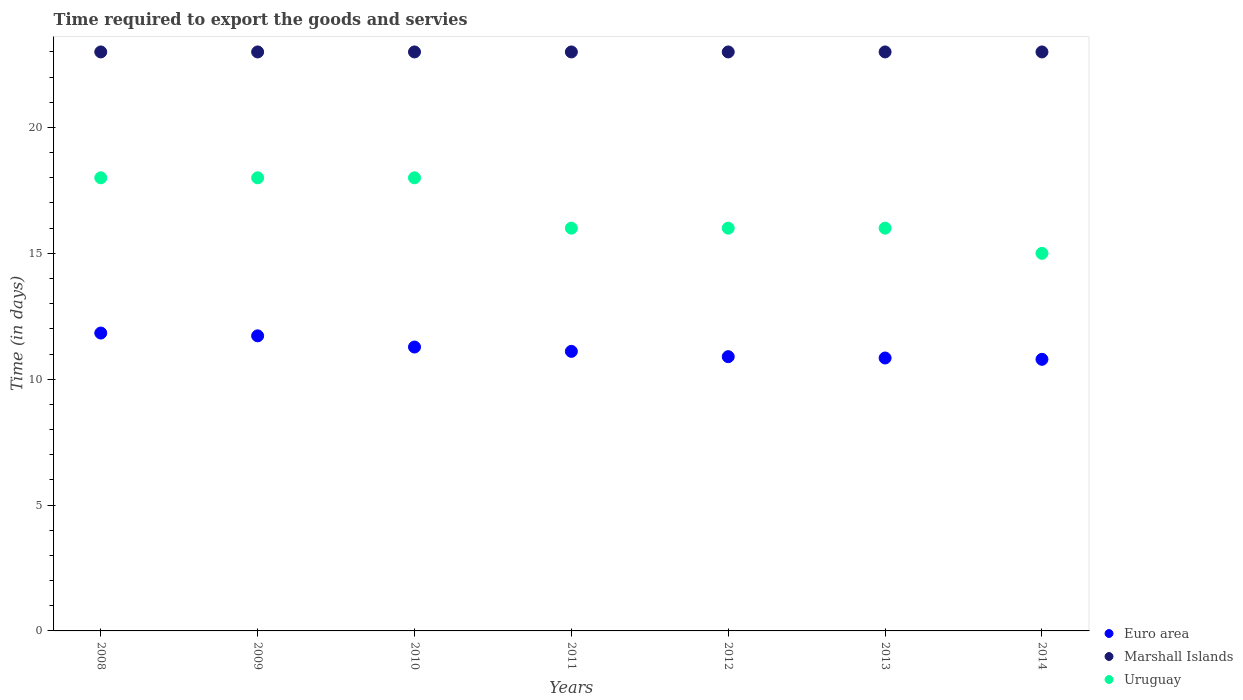Is the number of dotlines equal to the number of legend labels?
Your answer should be very brief. Yes. What is the number of days required to export the goods and services in Marshall Islands in 2014?
Keep it short and to the point. 23. Across all years, what is the maximum number of days required to export the goods and services in Marshall Islands?
Your answer should be very brief. 23. Across all years, what is the minimum number of days required to export the goods and services in Euro area?
Provide a succinct answer. 10.79. In which year was the number of days required to export the goods and services in Marshall Islands maximum?
Your response must be concise. 2008. In which year was the number of days required to export the goods and services in Marshall Islands minimum?
Provide a short and direct response. 2008. What is the total number of days required to export the goods and services in Marshall Islands in the graph?
Keep it short and to the point. 161. What is the difference between the number of days required to export the goods and services in Uruguay in 2013 and the number of days required to export the goods and services in Marshall Islands in 2010?
Make the answer very short. -7. What is the average number of days required to export the goods and services in Marshall Islands per year?
Offer a very short reply. 23. In the year 2012, what is the difference between the number of days required to export the goods and services in Euro area and number of days required to export the goods and services in Uruguay?
Your response must be concise. -5.11. What is the ratio of the number of days required to export the goods and services in Uruguay in 2012 to that in 2014?
Offer a very short reply. 1.07. Is the number of days required to export the goods and services in Uruguay in 2009 less than that in 2010?
Your response must be concise. No. Is the difference between the number of days required to export the goods and services in Euro area in 2008 and 2011 greater than the difference between the number of days required to export the goods and services in Uruguay in 2008 and 2011?
Make the answer very short. No. What is the difference between the highest and the second highest number of days required to export the goods and services in Marshall Islands?
Provide a succinct answer. 0. What is the difference between the highest and the lowest number of days required to export the goods and services in Euro area?
Your response must be concise. 1.04. In how many years, is the number of days required to export the goods and services in Uruguay greater than the average number of days required to export the goods and services in Uruguay taken over all years?
Your response must be concise. 3. Does the graph contain any zero values?
Give a very brief answer. No. Does the graph contain grids?
Offer a terse response. No. What is the title of the graph?
Ensure brevity in your answer.  Time required to export the goods and servies. Does "Switzerland" appear as one of the legend labels in the graph?
Ensure brevity in your answer.  No. What is the label or title of the X-axis?
Your answer should be compact. Years. What is the label or title of the Y-axis?
Keep it short and to the point. Time (in days). What is the Time (in days) of Euro area in 2008?
Your response must be concise. 11.83. What is the Time (in days) of Uruguay in 2008?
Your answer should be compact. 18. What is the Time (in days) in Euro area in 2009?
Offer a very short reply. 11.72. What is the Time (in days) in Uruguay in 2009?
Your response must be concise. 18. What is the Time (in days) in Euro area in 2010?
Provide a succinct answer. 11.28. What is the Time (in days) in Marshall Islands in 2010?
Provide a short and direct response. 23. What is the Time (in days) in Uruguay in 2010?
Ensure brevity in your answer.  18. What is the Time (in days) of Euro area in 2011?
Your response must be concise. 11.11. What is the Time (in days) in Euro area in 2012?
Your answer should be very brief. 10.89. What is the Time (in days) in Uruguay in 2012?
Your answer should be very brief. 16. What is the Time (in days) in Euro area in 2013?
Keep it short and to the point. 10.84. What is the Time (in days) of Marshall Islands in 2013?
Give a very brief answer. 23. What is the Time (in days) of Euro area in 2014?
Your answer should be compact. 10.79. Across all years, what is the maximum Time (in days) of Euro area?
Keep it short and to the point. 11.83. Across all years, what is the maximum Time (in days) in Marshall Islands?
Provide a succinct answer. 23. Across all years, what is the minimum Time (in days) in Euro area?
Offer a very short reply. 10.79. Across all years, what is the minimum Time (in days) of Marshall Islands?
Your answer should be compact. 23. Across all years, what is the minimum Time (in days) in Uruguay?
Your answer should be very brief. 15. What is the total Time (in days) in Euro area in the graph?
Ensure brevity in your answer.  78.46. What is the total Time (in days) of Marshall Islands in the graph?
Your answer should be very brief. 161. What is the total Time (in days) of Uruguay in the graph?
Ensure brevity in your answer.  117. What is the difference between the Time (in days) in Euro area in 2008 and that in 2009?
Your answer should be very brief. 0.11. What is the difference between the Time (in days) of Euro area in 2008 and that in 2010?
Provide a succinct answer. 0.56. What is the difference between the Time (in days) of Euro area in 2008 and that in 2011?
Give a very brief answer. 0.73. What is the difference between the Time (in days) of Euro area in 2008 and that in 2012?
Ensure brevity in your answer.  0.94. What is the difference between the Time (in days) in Euro area in 2008 and that in 2014?
Offer a terse response. 1.04. What is the difference between the Time (in days) of Euro area in 2009 and that in 2010?
Your answer should be compact. 0.44. What is the difference between the Time (in days) of Euro area in 2009 and that in 2011?
Your response must be concise. 0.62. What is the difference between the Time (in days) of Marshall Islands in 2009 and that in 2011?
Your answer should be very brief. 0. What is the difference between the Time (in days) of Uruguay in 2009 and that in 2011?
Make the answer very short. 2. What is the difference between the Time (in days) of Euro area in 2009 and that in 2012?
Offer a very short reply. 0.83. What is the difference between the Time (in days) of Marshall Islands in 2009 and that in 2012?
Make the answer very short. 0. What is the difference between the Time (in days) in Euro area in 2009 and that in 2013?
Your answer should be compact. 0.88. What is the difference between the Time (in days) of Marshall Islands in 2009 and that in 2013?
Your answer should be compact. 0. What is the difference between the Time (in days) in Uruguay in 2009 and that in 2013?
Give a very brief answer. 2. What is the difference between the Time (in days) in Euro area in 2009 and that in 2014?
Your response must be concise. 0.93. What is the difference between the Time (in days) of Marshall Islands in 2009 and that in 2014?
Provide a short and direct response. 0. What is the difference between the Time (in days) of Euro area in 2010 and that in 2011?
Your response must be concise. 0.17. What is the difference between the Time (in days) in Euro area in 2010 and that in 2012?
Give a very brief answer. 0.38. What is the difference between the Time (in days) in Marshall Islands in 2010 and that in 2012?
Your answer should be very brief. 0. What is the difference between the Time (in days) of Euro area in 2010 and that in 2013?
Your answer should be compact. 0.44. What is the difference between the Time (in days) in Marshall Islands in 2010 and that in 2013?
Offer a terse response. 0. What is the difference between the Time (in days) of Euro area in 2010 and that in 2014?
Provide a short and direct response. 0.49. What is the difference between the Time (in days) of Marshall Islands in 2010 and that in 2014?
Offer a terse response. 0. What is the difference between the Time (in days) in Uruguay in 2010 and that in 2014?
Your answer should be very brief. 3. What is the difference between the Time (in days) in Euro area in 2011 and that in 2012?
Your response must be concise. 0.21. What is the difference between the Time (in days) in Marshall Islands in 2011 and that in 2012?
Offer a very short reply. 0. What is the difference between the Time (in days) of Uruguay in 2011 and that in 2012?
Provide a succinct answer. 0. What is the difference between the Time (in days) of Euro area in 2011 and that in 2013?
Make the answer very short. 0.26. What is the difference between the Time (in days) of Uruguay in 2011 and that in 2013?
Keep it short and to the point. 0. What is the difference between the Time (in days) in Euro area in 2011 and that in 2014?
Provide a succinct answer. 0.32. What is the difference between the Time (in days) of Uruguay in 2011 and that in 2014?
Ensure brevity in your answer.  1. What is the difference between the Time (in days) of Euro area in 2012 and that in 2013?
Provide a succinct answer. 0.05. What is the difference between the Time (in days) of Marshall Islands in 2012 and that in 2013?
Provide a succinct answer. 0. What is the difference between the Time (in days) in Uruguay in 2012 and that in 2013?
Your response must be concise. 0. What is the difference between the Time (in days) in Euro area in 2012 and that in 2014?
Ensure brevity in your answer.  0.11. What is the difference between the Time (in days) in Marshall Islands in 2012 and that in 2014?
Give a very brief answer. 0. What is the difference between the Time (in days) of Euro area in 2013 and that in 2014?
Your answer should be very brief. 0.05. What is the difference between the Time (in days) in Marshall Islands in 2013 and that in 2014?
Keep it short and to the point. 0. What is the difference between the Time (in days) in Euro area in 2008 and the Time (in days) in Marshall Islands in 2009?
Your response must be concise. -11.17. What is the difference between the Time (in days) in Euro area in 2008 and the Time (in days) in Uruguay in 2009?
Make the answer very short. -6.17. What is the difference between the Time (in days) in Marshall Islands in 2008 and the Time (in days) in Uruguay in 2009?
Provide a short and direct response. 5. What is the difference between the Time (in days) in Euro area in 2008 and the Time (in days) in Marshall Islands in 2010?
Your answer should be compact. -11.17. What is the difference between the Time (in days) in Euro area in 2008 and the Time (in days) in Uruguay in 2010?
Give a very brief answer. -6.17. What is the difference between the Time (in days) in Euro area in 2008 and the Time (in days) in Marshall Islands in 2011?
Ensure brevity in your answer.  -11.17. What is the difference between the Time (in days) of Euro area in 2008 and the Time (in days) of Uruguay in 2011?
Your response must be concise. -4.17. What is the difference between the Time (in days) in Euro area in 2008 and the Time (in days) in Marshall Islands in 2012?
Offer a very short reply. -11.17. What is the difference between the Time (in days) of Euro area in 2008 and the Time (in days) of Uruguay in 2012?
Provide a short and direct response. -4.17. What is the difference between the Time (in days) of Euro area in 2008 and the Time (in days) of Marshall Islands in 2013?
Ensure brevity in your answer.  -11.17. What is the difference between the Time (in days) in Euro area in 2008 and the Time (in days) in Uruguay in 2013?
Your response must be concise. -4.17. What is the difference between the Time (in days) in Marshall Islands in 2008 and the Time (in days) in Uruguay in 2013?
Your answer should be very brief. 7. What is the difference between the Time (in days) in Euro area in 2008 and the Time (in days) in Marshall Islands in 2014?
Offer a terse response. -11.17. What is the difference between the Time (in days) of Euro area in 2008 and the Time (in days) of Uruguay in 2014?
Your answer should be very brief. -3.17. What is the difference between the Time (in days) of Euro area in 2009 and the Time (in days) of Marshall Islands in 2010?
Keep it short and to the point. -11.28. What is the difference between the Time (in days) in Euro area in 2009 and the Time (in days) in Uruguay in 2010?
Provide a short and direct response. -6.28. What is the difference between the Time (in days) in Euro area in 2009 and the Time (in days) in Marshall Islands in 2011?
Make the answer very short. -11.28. What is the difference between the Time (in days) of Euro area in 2009 and the Time (in days) of Uruguay in 2011?
Your answer should be compact. -4.28. What is the difference between the Time (in days) of Euro area in 2009 and the Time (in days) of Marshall Islands in 2012?
Your response must be concise. -11.28. What is the difference between the Time (in days) in Euro area in 2009 and the Time (in days) in Uruguay in 2012?
Offer a terse response. -4.28. What is the difference between the Time (in days) of Marshall Islands in 2009 and the Time (in days) of Uruguay in 2012?
Make the answer very short. 7. What is the difference between the Time (in days) in Euro area in 2009 and the Time (in days) in Marshall Islands in 2013?
Your answer should be very brief. -11.28. What is the difference between the Time (in days) in Euro area in 2009 and the Time (in days) in Uruguay in 2013?
Offer a terse response. -4.28. What is the difference between the Time (in days) of Euro area in 2009 and the Time (in days) of Marshall Islands in 2014?
Your response must be concise. -11.28. What is the difference between the Time (in days) in Euro area in 2009 and the Time (in days) in Uruguay in 2014?
Offer a very short reply. -3.28. What is the difference between the Time (in days) in Marshall Islands in 2009 and the Time (in days) in Uruguay in 2014?
Your answer should be compact. 8. What is the difference between the Time (in days) in Euro area in 2010 and the Time (in days) in Marshall Islands in 2011?
Keep it short and to the point. -11.72. What is the difference between the Time (in days) of Euro area in 2010 and the Time (in days) of Uruguay in 2011?
Make the answer very short. -4.72. What is the difference between the Time (in days) in Euro area in 2010 and the Time (in days) in Marshall Islands in 2012?
Make the answer very short. -11.72. What is the difference between the Time (in days) in Euro area in 2010 and the Time (in days) in Uruguay in 2012?
Provide a short and direct response. -4.72. What is the difference between the Time (in days) in Marshall Islands in 2010 and the Time (in days) in Uruguay in 2012?
Your response must be concise. 7. What is the difference between the Time (in days) in Euro area in 2010 and the Time (in days) in Marshall Islands in 2013?
Give a very brief answer. -11.72. What is the difference between the Time (in days) of Euro area in 2010 and the Time (in days) of Uruguay in 2013?
Offer a very short reply. -4.72. What is the difference between the Time (in days) in Marshall Islands in 2010 and the Time (in days) in Uruguay in 2013?
Offer a terse response. 7. What is the difference between the Time (in days) in Euro area in 2010 and the Time (in days) in Marshall Islands in 2014?
Ensure brevity in your answer.  -11.72. What is the difference between the Time (in days) of Euro area in 2010 and the Time (in days) of Uruguay in 2014?
Provide a succinct answer. -3.72. What is the difference between the Time (in days) in Marshall Islands in 2010 and the Time (in days) in Uruguay in 2014?
Offer a very short reply. 8. What is the difference between the Time (in days) of Euro area in 2011 and the Time (in days) of Marshall Islands in 2012?
Make the answer very short. -11.89. What is the difference between the Time (in days) of Euro area in 2011 and the Time (in days) of Uruguay in 2012?
Provide a short and direct response. -4.89. What is the difference between the Time (in days) of Marshall Islands in 2011 and the Time (in days) of Uruguay in 2012?
Ensure brevity in your answer.  7. What is the difference between the Time (in days) of Euro area in 2011 and the Time (in days) of Marshall Islands in 2013?
Keep it short and to the point. -11.89. What is the difference between the Time (in days) of Euro area in 2011 and the Time (in days) of Uruguay in 2013?
Provide a succinct answer. -4.89. What is the difference between the Time (in days) of Marshall Islands in 2011 and the Time (in days) of Uruguay in 2013?
Your answer should be compact. 7. What is the difference between the Time (in days) of Euro area in 2011 and the Time (in days) of Marshall Islands in 2014?
Your response must be concise. -11.89. What is the difference between the Time (in days) of Euro area in 2011 and the Time (in days) of Uruguay in 2014?
Ensure brevity in your answer.  -3.89. What is the difference between the Time (in days) of Euro area in 2012 and the Time (in days) of Marshall Islands in 2013?
Your response must be concise. -12.11. What is the difference between the Time (in days) in Euro area in 2012 and the Time (in days) in Uruguay in 2013?
Your answer should be compact. -5.11. What is the difference between the Time (in days) in Euro area in 2012 and the Time (in days) in Marshall Islands in 2014?
Your answer should be compact. -12.11. What is the difference between the Time (in days) of Euro area in 2012 and the Time (in days) of Uruguay in 2014?
Provide a succinct answer. -4.11. What is the difference between the Time (in days) of Euro area in 2013 and the Time (in days) of Marshall Islands in 2014?
Provide a short and direct response. -12.16. What is the difference between the Time (in days) in Euro area in 2013 and the Time (in days) in Uruguay in 2014?
Offer a terse response. -4.16. What is the average Time (in days) of Euro area per year?
Ensure brevity in your answer.  11.21. What is the average Time (in days) of Marshall Islands per year?
Provide a succinct answer. 23. What is the average Time (in days) in Uruguay per year?
Provide a succinct answer. 16.71. In the year 2008, what is the difference between the Time (in days) of Euro area and Time (in days) of Marshall Islands?
Ensure brevity in your answer.  -11.17. In the year 2008, what is the difference between the Time (in days) in Euro area and Time (in days) in Uruguay?
Your response must be concise. -6.17. In the year 2008, what is the difference between the Time (in days) in Marshall Islands and Time (in days) in Uruguay?
Your response must be concise. 5. In the year 2009, what is the difference between the Time (in days) in Euro area and Time (in days) in Marshall Islands?
Provide a short and direct response. -11.28. In the year 2009, what is the difference between the Time (in days) of Euro area and Time (in days) of Uruguay?
Offer a terse response. -6.28. In the year 2010, what is the difference between the Time (in days) of Euro area and Time (in days) of Marshall Islands?
Your answer should be compact. -11.72. In the year 2010, what is the difference between the Time (in days) of Euro area and Time (in days) of Uruguay?
Your response must be concise. -6.72. In the year 2010, what is the difference between the Time (in days) in Marshall Islands and Time (in days) in Uruguay?
Give a very brief answer. 5. In the year 2011, what is the difference between the Time (in days) of Euro area and Time (in days) of Marshall Islands?
Your response must be concise. -11.89. In the year 2011, what is the difference between the Time (in days) in Euro area and Time (in days) in Uruguay?
Ensure brevity in your answer.  -4.89. In the year 2012, what is the difference between the Time (in days) of Euro area and Time (in days) of Marshall Islands?
Provide a short and direct response. -12.11. In the year 2012, what is the difference between the Time (in days) in Euro area and Time (in days) in Uruguay?
Make the answer very short. -5.11. In the year 2012, what is the difference between the Time (in days) of Marshall Islands and Time (in days) of Uruguay?
Your answer should be very brief. 7. In the year 2013, what is the difference between the Time (in days) of Euro area and Time (in days) of Marshall Islands?
Provide a short and direct response. -12.16. In the year 2013, what is the difference between the Time (in days) of Euro area and Time (in days) of Uruguay?
Offer a very short reply. -5.16. In the year 2014, what is the difference between the Time (in days) of Euro area and Time (in days) of Marshall Islands?
Your answer should be very brief. -12.21. In the year 2014, what is the difference between the Time (in days) in Euro area and Time (in days) in Uruguay?
Provide a succinct answer. -4.21. In the year 2014, what is the difference between the Time (in days) in Marshall Islands and Time (in days) in Uruguay?
Offer a terse response. 8. What is the ratio of the Time (in days) in Euro area in 2008 to that in 2009?
Ensure brevity in your answer.  1.01. What is the ratio of the Time (in days) of Uruguay in 2008 to that in 2009?
Offer a terse response. 1. What is the ratio of the Time (in days) of Euro area in 2008 to that in 2010?
Provide a short and direct response. 1.05. What is the ratio of the Time (in days) of Euro area in 2008 to that in 2011?
Ensure brevity in your answer.  1.07. What is the ratio of the Time (in days) of Uruguay in 2008 to that in 2011?
Ensure brevity in your answer.  1.12. What is the ratio of the Time (in days) of Euro area in 2008 to that in 2012?
Provide a succinct answer. 1.09. What is the ratio of the Time (in days) in Marshall Islands in 2008 to that in 2012?
Keep it short and to the point. 1. What is the ratio of the Time (in days) of Uruguay in 2008 to that in 2012?
Keep it short and to the point. 1.12. What is the ratio of the Time (in days) in Euro area in 2008 to that in 2013?
Ensure brevity in your answer.  1.09. What is the ratio of the Time (in days) in Marshall Islands in 2008 to that in 2013?
Keep it short and to the point. 1. What is the ratio of the Time (in days) of Euro area in 2008 to that in 2014?
Make the answer very short. 1.1. What is the ratio of the Time (in days) of Euro area in 2009 to that in 2010?
Give a very brief answer. 1.04. What is the ratio of the Time (in days) of Euro area in 2009 to that in 2011?
Offer a very short reply. 1.06. What is the ratio of the Time (in days) in Marshall Islands in 2009 to that in 2011?
Ensure brevity in your answer.  1. What is the ratio of the Time (in days) in Euro area in 2009 to that in 2012?
Your response must be concise. 1.08. What is the ratio of the Time (in days) in Euro area in 2009 to that in 2013?
Keep it short and to the point. 1.08. What is the ratio of the Time (in days) in Euro area in 2009 to that in 2014?
Your answer should be very brief. 1.09. What is the ratio of the Time (in days) in Euro area in 2010 to that in 2011?
Ensure brevity in your answer.  1.02. What is the ratio of the Time (in days) in Euro area in 2010 to that in 2012?
Your response must be concise. 1.04. What is the ratio of the Time (in days) of Uruguay in 2010 to that in 2012?
Your response must be concise. 1.12. What is the ratio of the Time (in days) of Euro area in 2010 to that in 2013?
Your answer should be very brief. 1.04. What is the ratio of the Time (in days) in Marshall Islands in 2010 to that in 2013?
Make the answer very short. 1. What is the ratio of the Time (in days) in Euro area in 2010 to that in 2014?
Provide a short and direct response. 1.05. What is the ratio of the Time (in days) of Marshall Islands in 2010 to that in 2014?
Offer a very short reply. 1. What is the ratio of the Time (in days) in Uruguay in 2010 to that in 2014?
Keep it short and to the point. 1.2. What is the ratio of the Time (in days) of Euro area in 2011 to that in 2012?
Offer a terse response. 1.02. What is the ratio of the Time (in days) of Euro area in 2011 to that in 2013?
Make the answer very short. 1.02. What is the ratio of the Time (in days) of Uruguay in 2011 to that in 2013?
Offer a very short reply. 1. What is the ratio of the Time (in days) in Euro area in 2011 to that in 2014?
Your response must be concise. 1.03. What is the ratio of the Time (in days) in Uruguay in 2011 to that in 2014?
Provide a succinct answer. 1.07. What is the ratio of the Time (in days) in Euro area in 2012 to that in 2013?
Keep it short and to the point. 1. What is the ratio of the Time (in days) of Marshall Islands in 2012 to that in 2013?
Offer a terse response. 1. What is the ratio of the Time (in days) of Uruguay in 2012 to that in 2013?
Ensure brevity in your answer.  1. What is the ratio of the Time (in days) in Euro area in 2012 to that in 2014?
Give a very brief answer. 1.01. What is the ratio of the Time (in days) in Marshall Islands in 2012 to that in 2014?
Your answer should be very brief. 1. What is the ratio of the Time (in days) of Uruguay in 2012 to that in 2014?
Offer a terse response. 1.07. What is the ratio of the Time (in days) in Euro area in 2013 to that in 2014?
Give a very brief answer. 1. What is the ratio of the Time (in days) in Uruguay in 2013 to that in 2014?
Make the answer very short. 1.07. What is the difference between the highest and the second highest Time (in days) in Marshall Islands?
Your answer should be compact. 0. What is the difference between the highest and the lowest Time (in days) in Euro area?
Offer a very short reply. 1.04. 